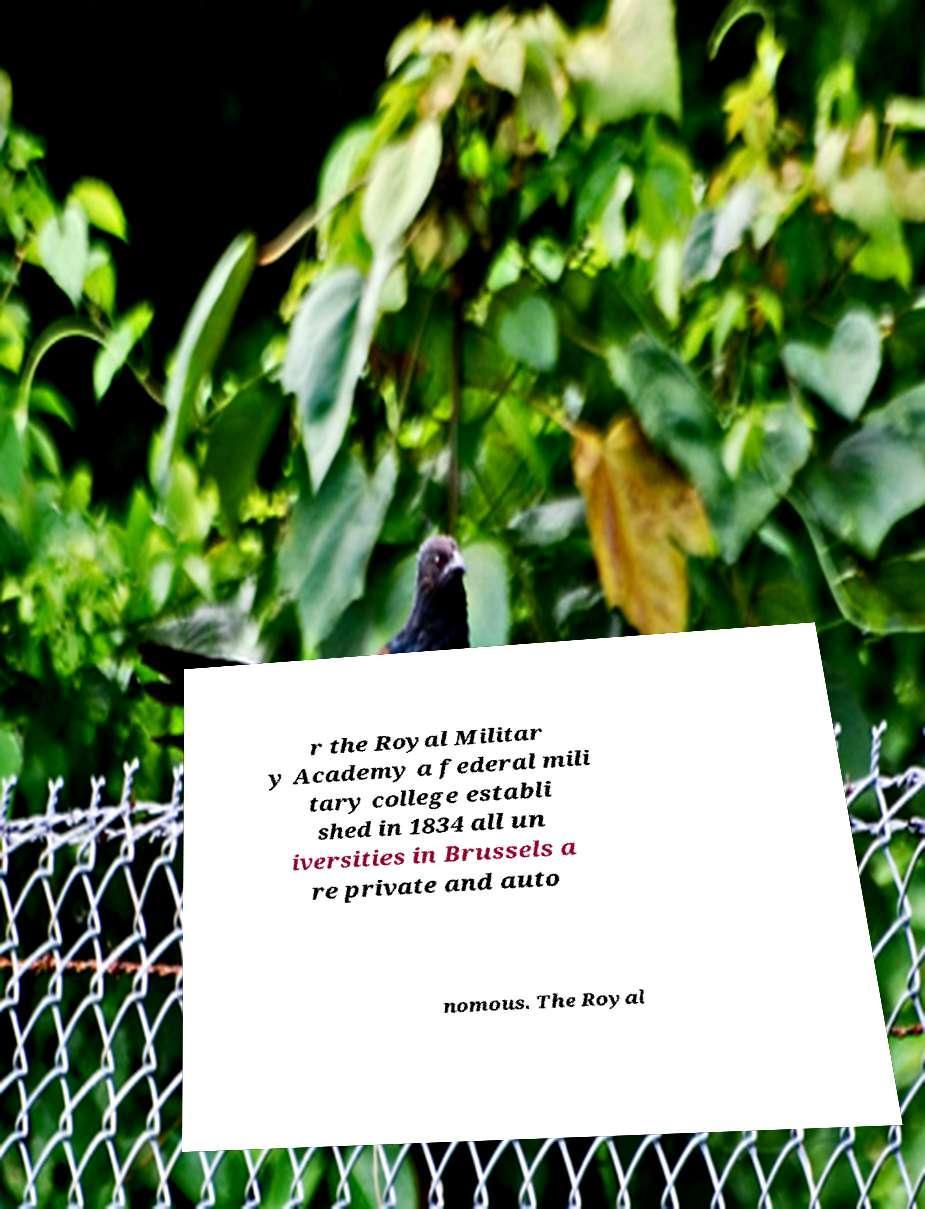Can you read and provide the text displayed in the image?This photo seems to have some interesting text. Can you extract and type it out for me? r the Royal Militar y Academy a federal mili tary college establi shed in 1834 all un iversities in Brussels a re private and auto nomous. The Royal 